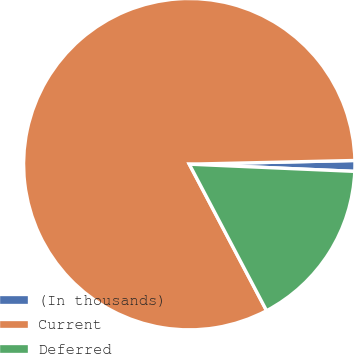Convert chart to OTSL. <chart><loc_0><loc_0><loc_500><loc_500><pie_chart><fcel>(In thousands)<fcel>Current<fcel>Deferred<nl><fcel>1.05%<fcel>82.37%<fcel>16.58%<nl></chart> 